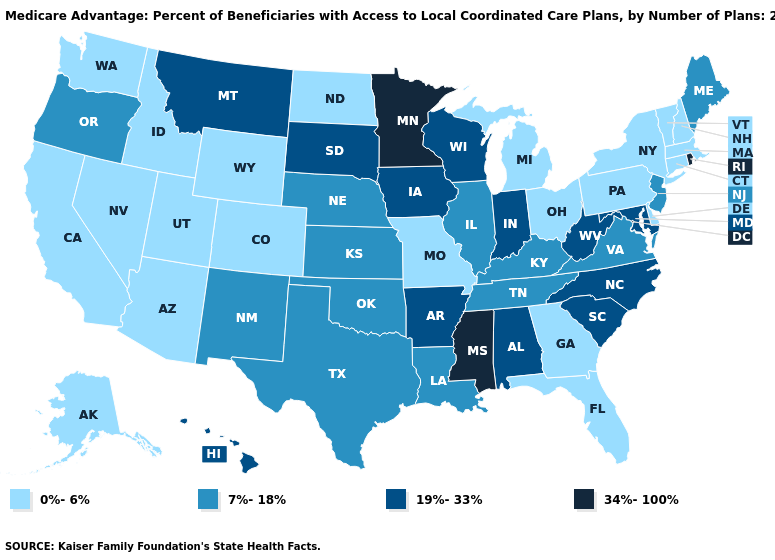Among the states that border Kentucky , does West Virginia have the highest value?
Be succinct. Yes. Name the states that have a value in the range 0%-6%?
Short answer required. Alaska, Arizona, California, Colorado, Connecticut, Delaware, Florida, Georgia, Idaho, Massachusetts, Michigan, Missouri, North Dakota, New Hampshire, Nevada, New York, Ohio, Pennsylvania, Utah, Vermont, Washington, Wyoming. What is the highest value in states that border Alabama?
Be succinct. 34%-100%. What is the value of Wisconsin?
Keep it brief. 19%-33%. What is the value of Michigan?
Answer briefly. 0%-6%. Among the states that border Maryland , which have the highest value?
Be succinct. West Virginia. What is the value of Illinois?
Give a very brief answer. 7%-18%. What is the lowest value in states that border Minnesota?
Short answer required. 0%-6%. Does Connecticut have the same value as Kansas?
Write a very short answer. No. Does Louisiana have a lower value than South Dakota?
Write a very short answer. Yes. What is the highest value in states that border Oregon?
Keep it brief. 0%-6%. What is the value of New York?
Give a very brief answer. 0%-6%. Among the states that border Wyoming , which have the highest value?
Give a very brief answer. Montana, South Dakota. Among the states that border Pennsylvania , does Delaware have the lowest value?
Be succinct. Yes. 